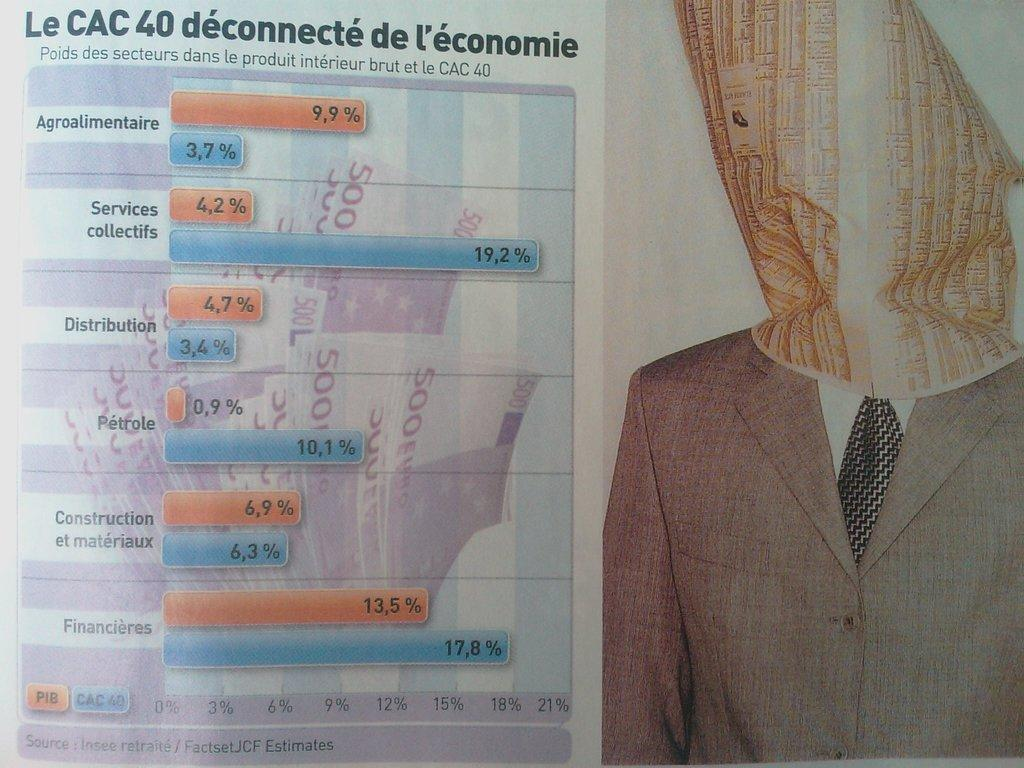What type of visual is the image? The image is a poster. What clothing items are depicted in the poster? We start by identifying the main subjects in the poster, which are a blazer and a tie. Then, we expand the conversation to include other items that are also visible, such as a paper, symbols, and text. Each question is designed to elicit a specific detail about the poster that is known from the provided facts. Absurd Question/Answer: What type of insurance is being advertised on the sidewalk in the poster? There is no mention of insurance or a sidewalk in the poster; it features a blazer, tie, paper, symbols, and text. What type of mine is depicted in the poster? There is no mine depicted in the poster; it features a blazer, tie, paper, symbols, and text. 